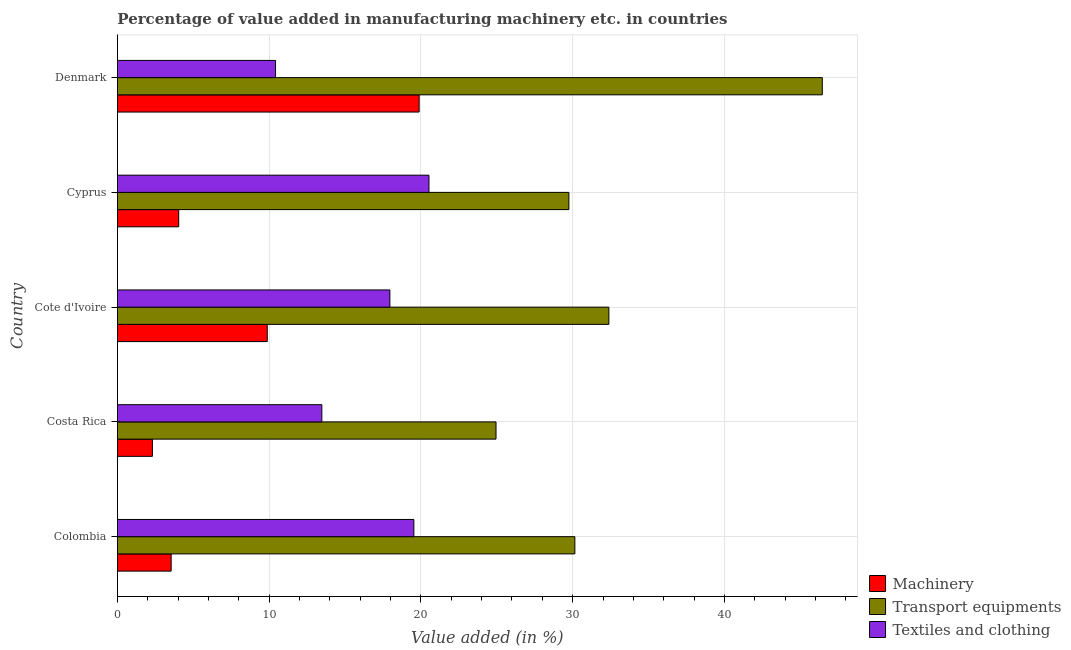How many groups of bars are there?
Keep it short and to the point. 5. Are the number of bars per tick equal to the number of legend labels?
Keep it short and to the point. Yes. How many bars are there on the 1st tick from the top?
Ensure brevity in your answer.  3. How many bars are there on the 3rd tick from the bottom?
Your answer should be very brief. 3. What is the label of the 2nd group of bars from the top?
Your response must be concise. Cyprus. In how many cases, is the number of bars for a given country not equal to the number of legend labels?
Keep it short and to the point. 0. What is the value added in manufacturing textile and clothing in Costa Rica?
Provide a short and direct response. 13.47. Across all countries, what is the maximum value added in manufacturing transport equipments?
Ensure brevity in your answer.  46.45. Across all countries, what is the minimum value added in manufacturing transport equipments?
Your answer should be very brief. 24.95. In which country was the value added in manufacturing textile and clothing maximum?
Provide a succinct answer. Cyprus. What is the total value added in manufacturing transport equipments in the graph?
Provide a short and direct response. 163.69. What is the difference between the value added in manufacturing machinery in Colombia and that in Cyprus?
Your answer should be compact. -0.5. What is the difference between the value added in manufacturing textile and clothing in Cote d'Ivoire and the value added in manufacturing transport equipments in Denmark?
Your response must be concise. -28.5. What is the average value added in manufacturing textile and clothing per country?
Ensure brevity in your answer.  16.38. What is the difference between the value added in manufacturing transport equipments and value added in manufacturing textile and clothing in Cyprus?
Offer a terse response. 9.22. What is the ratio of the value added in manufacturing transport equipments in Costa Rica to that in Cote d'Ivoire?
Give a very brief answer. 0.77. What is the difference between the highest and the second highest value added in manufacturing machinery?
Offer a very short reply. 10.01. In how many countries, is the value added in manufacturing machinery greater than the average value added in manufacturing machinery taken over all countries?
Your answer should be very brief. 2. What does the 1st bar from the top in Colombia represents?
Your answer should be very brief. Textiles and clothing. What does the 1st bar from the bottom in Cote d'Ivoire represents?
Offer a very short reply. Machinery. Is it the case that in every country, the sum of the value added in manufacturing machinery and value added in manufacturing transport equipments is greater than the value added in manufacturing textile and clothing?
Your answer should be very brief. Yes. How many bars are there?
Your answer should be very brief. 15. Are all the bars in the graph horizontal?
Your answer should be compact. Yes. How many countries are there in the graph?
Offer a terse response. 5. What is the difference between two consecutive major ticks on the X-axis?
Your answer should be compact. 10. Does the graph contain grids?
Keep it short and to the point. Yes. Where does the legend appear in the graph?
Offer a terse response. Bottom right. How many legend labels are there?
Provide a short and direct response. 3. What is the title of the graph?
Give a very brief answer. Percentage of value added in manufacturing machinery etc. in countries. What is the label or title of the X-axis?
Make the answer very short. Value added (in %). What is the Value added (in %) of Machinery in Colombia?
Provide a short and direct response. 3.54. What is the Value added (in %) in Transport equipments in Colombia?
Provide a succinct answer. 30.15. What is the Value added (in %) in Textiles and clothing in Colombia?
Ensure brevity in your answer.  19.54. What is the Value added (in %) in Machinery in Costa Rica?
Ensure brevity in your answer.  2.31. What is the Value added (in %) of Transport equipments in Costa Rica?
Make the answer very short. 24.95. What is the Value added (in %) of Textiles and clothing in Costa Rica?
Your response must be concise. 13.47. What is the Value added (in %) of Machinery in Cote d'Ivoire?
Provide a succinct answer. 9.88. What is the Value added (in %) of Transport equipments in Cote d'Ivoire?
Give a very brief answer. 32.39. What is the Value added (in %) in Textiles and clothing in Cote d'Ivoire?
Your response must be concise. 17.96. What is the Value added (in %) of Machinery in Cyprus?
Keep it short and to the point. 4.04. What is the Value added (in %) of Transport equipments in Cyprus?
Keep it short and to the point. 29.75. What is the Value added (in %) in Textiles and clothing in Cyprus?
Your answer should be very brief. 20.53. What is the Value added (in %) of Machinery in Denmark?
Provide a succinct answer. 19.88. What is the Value added (in %) of Transport equipments in Denmark?
Offer a terse response. 46.45. What is the Value added (in %) of Textiles and clothing in Denmark?
Offer a very short reply. 10.42. Across all countries, what is the maximum Value added (in %) in Machinery?
Give a very brief answer. 19.88. Across all countries, what is the maximum Value added (in %) in Transport equipments?
Provide a short and direct response. 46.45. Across all countries, what is the maximum Value added (in %) in Textiles and clothing?
Provide a short and direct response. 20.53. Across all countries, what is the minimum Value added (in %) in Machinery?
Offer a terse response. 2.31. Across all countries, what is the minimum Value added (in %) of Transport equipments?
Provide a succinct answer. 24.95. Across all countries, what is the minimum Value added (in %) of Textiles and clothing?
Your answer should be very brief. 10.42. What is the total Value added (in %) in Machinery in the graph?
Your answer should be very brief. 39.65. What is the total Value added (in %) in Transport equipments in the graph?
Provide a short and direct response. 163.69. What is the total Value added (in %) in Textiles and clothing in the graph?
Provide a short and direct response. 81.92. What is the difference between the Value added (in %) of Machinery in Colombia and that in Costa Rica?
Make the answer very short. 1.24. What is the difference between the Value added (in %) of Transport equipments in Colombia and that in Costa Rica?
Keep it short and to the point. 5.2. What is the difference between the Value added (in %) in Textiles and clothing in Colombia and that in Costa Rica?
Offer a terse response. 6.06. What is the difference between the Value added (in %) of Machinery in Colombia and that in Cote d'Ivoire?
Provide a succinct answer. -6.33. What is the difference between the Value added (in %) of Transport equipments in Colombia and that in Cote d'Ivoire?
Your answer should be very brief. -2.24. What is the difference between the Value added (in %) in Textiles and clothing in Colombia and that in Cote d'Ivoire?
Make the answer very short. 1.58. What is the difference between the Value added (in %) in Machinery in Colombia and that in Cyprus?
Your response must be concise. -0.5. What is the difference between the Value added (in %) of Transport equipments in Colombia and that in Cyprus?
Give a very brief answer. 0.39. What is the difference between the Value added (in %) of Textiles and clothing in Colombia and that in Cyprus?
Make the answer very short. -0.99. What is the difference between the Value added (in %) of Machinery in Colombia and that in Denmark?
Ensure brevity in your answer.  -16.34. What is the difference between the Value added (in %) in Transport equipments in Colombia and that in Denmark?
Your answer should be very brief. -16.31. What is the difference between the Value added (in %) in Textiles and clothing in Colombia and that in Denmark?
Keep it short and to the point. 9.12. What is the difference between the Value added (in %) of Machinery in Costa Rica and that in Cote d'Ivoire?
Offer a terse response. -7.57. What is the difference between the Value added (in %) in Transport equipments in Costa Rica and that in Cote d'Ivoire?
Offer a terse response. -7.44. What is the difference between the Value added (in %) in Textiles and clothing in Costa Rica and that in Cote d'Ivoire?
Ensure brevity in your answer.  -4.48. What is the difference between the Value added (in %) in Machinery in Costa Rica and that in Cyprus?
Offer a very short reply. -1.73. What is the difference between the Value added (in %) in Transport equipments in Costa Rica and that in Cyprus?
Make the answer very short. -4.8. What is the difference between the Value added (in %) in Textiles and clothing in Costa Rica and that in Cyprus?
Make the answer very short. -7.06. What is the difference between the Value added (in %) in Machinery in Costa Rica and that in Denmark?
Keep it short and to the point. -17.58. What is the difference between the Value added (in %) of Transport equipments in Costa Rica and that in Denmark?
Offer a very short reply. -21.5. What is the difference between the Value added (in %) of Textiles and clothing in Costa Rica and that in Denmark?
Ensure brevity in your answer.  3.05. What is the difference between the Value added (in %) of Machinery in Cote d'Ivoire and that in Cyprus?
Your answer should be compact. 5.84. What is the difference between the Value added (in %) in Transport equipments in Cote d'Ivoire and that in Cyprus?
Offer a terse response. 2.63. What is the difference between the Value added (in %) of Textiles and clothing in Cote d'Ivoire and that in Cyprus?
Offer a terse response. -2.58. What is the difference between the Value added (in %) of Machinery in Cote d'Ivoire and that in Denmark?
Offer a very short reply. -10.01. What is the difference between the Value added (in %) in Transport equipments in Cote d'Ivoire and that in Denmark?
Ensure brevity in your answer.  -14.06. What is the difference between the Value added (in %) of Textiles and clothing in Cote d'Ivoire and that in Denmark?
Your answer should be compact. 7.53. What is the difference between the Value added (in %) in Machinery in Cyprus and that in Denmark?
Ensure brevity in your answer.  -15.84. What is the difference between the Value added (in %) in Transport equipments in Cyprus and that in Denmark?
Your answer should be compact. -16.7. What is the difference between the Value added (in %) of Textiles and clothing in Cyprus and that in Denmark?
Give a very brief answer. 10.11. What is the difference between the Value added (in %) of Machinery in Colombia and the Value added (in %) of Transport equipments in Costa Rica?
Provide a succinct answer. -21.41. What is the difference between the Value added (in %) of Machinery in Colombia and the Value added (in %) of Textiles and clothing in Costa Rica?
Make the answer very short. -9.93. What is the difference between the Value added (in %) of Transport equipments in Colombia and the Value added (in %) of Textiles and clothing in Costa Rica?
Offer a terse response. 16.67. What is the difference between the Value added (in %) in Machinery in Colombia and the Value added (in %) in Transport equipments in Cote d'Ivoire?
Ensure brevity in your answer.  -28.85. What is the difference between the Value added (in %) in Machinery in Colombia and the Value added (in %) in Textiles and clothing in Cote d'Ivoire?
Your response must be concise. -14.41. What is the difference between the Value added (in %) in Transport equipments in Colombia and the Value added (in %) in Textiles and clothing in Cote d'Ivoire?
Ensure brevity in your answer.  12.19. What is the difference between the Value added (in %) in Machinery in Colombia and the Value added (in %) in Transport equipments in Cyprus?
Your answer should be very brief. -26.21. What is the difference between the Value added (in %) of Machinery in Colombia and the Value added (in %) of Textiles and clothing in Cyprus?
Keep it short and to the point. -16.99. What is the difference between the Value added (in %) of Transport equipments in Colombia and the Value added (in %) of Textiles and clothing in Cyprus?
Give a very brief answer. 9.61. What is the difference between the Value added (in %) of Machinery in Colombia and the Value added (in %) of Transport equipments in Denmark?
Keep it short and to the point. -42.91. What is the difference between the Value added (in %) of Machinery in Colombia and the Value added (in %) of Textiles and clothing in Denmark?
Provide a succinct answer. -6.88. What is the difference between the Value added (in %) in Transport equipments in Colombia and the Value added (in %) in Textiles and clothing in Denmark?
Offer a terse response. 19.72. What is the difference between the Value added (in %) in Machinery in Costa Rica and the Value added (in %) in Transport equipments in Cote d'Ivoire?
Provide a succinct answer. -30.08. What is the difference between the Value added (in %) in Machinery in Costa Rica and the Value added (in %) in Textiles and clothing in Cote d'Ivoire?
Provide a short and direct response. -15.65. What is the difference between the Value added (in %) of Transport equipments in Costa Rica and the Value added (in %) of Textiles and clothing in Cote d'Ivoire?
Your response must be concise. 6.99. What is the difference between the Value added (in %) of Machinery in Costa Rica and the Value added (in %) of Transport equipments in Cyprus?
Give a very brief answer. -27.45. What is the difference between the Value added (in %) in Machinery in Costa Rica and the Value added (in %) in Textiles and clothing in Cyprus?
Ensure brevity in your answer.  -18.23. What is the difference between the Value added (in %) of Transport equipments in Costa Rica and the Value added (in %) of Textiles and clothing in Cyprus?
Your response must be concise. 4.42. What is the difference between the Value added (in %) of Machinery in Costa Rica and the Value added (in %) of Transport equipments in Denmark?
Your response must be concise. -44.15. What is the difference between the Value added (in %) of Machinery in Costa Rica and the Value added (in %) of Textiles and clothing in Denmark?
Offer a very short reply. -8.11. What is the difference between the Value added (in %) of Transport equipments in Costa Rica and the Value added (in %) of Textiles and clothing in Denmark?
Offer a terse response. 14.53. What is the difference between the Value added (in %) of Machinery in Cote d'Ivoire and the Value added (in %) of Transport equipments in Cyprus?
Offer a very short reply. -19.88. What is the difference between the Value added (in %) of Machinery in Cote d'Ivoire and the Value added (in %) of Textiles and clothing in Cyprus?
Provide a succinct answer. -10.66. What is the difference between the Value added (in %) in Transport equipments in Cote d'Ivoire and the Value added (in %) in Textiles and clothing in Cyprus?
Ensure brevity in your answer.  11.86. What is the difference between the Value added (in %) in Machinery in Cote d'Ivoire and the Value added (in %) in Transport equipments in Denmark?
Offer a terse response. -36.58. What is the difference between the Value added (in %) in Machinery in Cote d'Ivoire and the Value added (in %) in Textiles and clothing in Denmark?
Make the answer very short. -0.55. What is the difference between the Value added (in %) of Transport equipments in Cote d'Ivoire and the Value added (in %) of Textiles and clothing in Denmark?
Your answer should be very brief. 21.97. What is the difference between the Value added (in %) of Machinery in Cyprus and the Value added (in %) of Transport equipments in Denmark?
Provide a short and direct response. -42.41. What is the difference between the Value added (in %) in Machinery in Cyprus and the Value added (in %) in Textiles and clothing in Denmark?
Your answer should be very brief. -6.38. What is the difference between the Value added (in %) of Transport equipments in Cyprus and the Value added (in %) of Textiles and clothing in Denmark?
Give a very brief answer. 19.33. What is the average Value added (in %) of Machinery per country?
Make the answer very short. 7.93. What is the average Value added (in %) of Transport equipments per country?
Ensure brevity in your answer.  32.74. What is the average Value added (in %) of Textiles and clothing per country?
Ensure brevity in your answer.  16.38. What is the difference between the Value added (in %) of Machinery and Value added (in %) of Transport equipments in Colombia?
Provide a short and direct response. -26.6. What is the difference between the Value added (in %) of Machinery and Value added (in %) of Textiles and clothing in Colombia?
Give a very brief answer. -15.99. What is the difference between the Value added (in %) of Transport equipments and Value added (in %) of Textiles and clothing in Colombia?
Your answer should be very brief. 10.61. What is the difference between the Value added (in %) in Machinery and Value added (in %) in Transport equipments in Costa Rica?
Your answer should be compact. -22.64. What is the difference between the Value added (in %) of Machinery and Value added (in %) of Textiles and clothing in Costa Rica?
Provide a succinct answer. -11.17. What is the difference between the Value added (in %) in Transport equipments and Value added (in %) in Textiles and clothing in Costa Rica?
Give a very brief answer. 11.48. What is the difference between the Value added (in %) of Machinery and Value added (in %) of Transport equipments in Cote d'Ivoire?
Your answer should be very brief. -22.51. What is the difference between the Value added (in %) in Machinery and Value added (in %) in Textiles and clothing in Cote d'Ivoire?
Provide a succinct answer. -8.08. What is the difference between the Value added (in %) in Transport equipments and Value added (in %) in Textiles and clothing in Cote d'Ivoire?
Provide a short and direct response. 14.43. What is the difference between the Value added (in %) of Machinery and Value added (in %) of Transport equipments in Cyprus?
Give a very brief answer. -25.71. What is the difference between the Value added (in %) of Machinery and Value added (in %) of Textiles and clothing in Cyprus?
Your answer should be very brief. -16.49. What is the difference between the Value added (in %) of Transport equipments and Value added (in %) of Textiles and clothing in Cyprus?
Ensure brevity in your answer.  9.22. What is the difference between the Value added (in %) of Machinery and Value added (in %) of Transport equipments in Denmark?
Give a very brief answer. -26.57. What is the difference between the Value added (in %) of Machinery and Value added (in %) of Textiles and clothing in Denmark?
Make the answer very short. 9.46. What is the difference between the Value added (in %) of Transport equipments and Value added (in %) of Textiles and clothing in Denmark?
Keep it short and to the point. 36.03. What is the ratio of the Value added (in %) of Machinery in Colombia to that in Costa Rica?
Your answer should be compact. 1.54. What is the ratio of the Value added (in %) in Transport equipments in Colombia to that in Costa Rica?
Make the answer very short. 1.21. What is the ratio of the Value added (in %) of Textiles and clothing in Colombia to that in Costa Rica?
Your answer should be very brief. 1.45. What is the ratio of the Value added (in %) of Machinery in Colombia to that in Cote d'Ivoire?
Provide a short and direct response. 0.36. What is the ratio of the Value added (in %) in Transport equipments in Colombia to that in Cote d'Ivoire?
Your answer should be very brief. 0.93. What is the ratio of the Value added (in %) in Textiles and clothing in Colombia to that in Cote d'Ivoire?
Your answer should be compact. 1.09. What is the ratio of the Value added (in %) of Machinery in Colombia to that in Cyprus?
Ensure brevity in your answer.  0.88. What is the ratio of the Value added (in %) in Transport equipments in Colombia to that in Cyprus?
Provide a short and direct response. 1.01. What is the ratio of the Value added (in %) in Textiles and clothing in Colombia to that in Cyprus?
Provide a short and direct response. 0.95. What is the ratio of the Value added (in %) in Machinery in Colombia to that in Denmark?
Offer a very short reply. 0.18. What is the ratio of the Value added (in %) in Transport equipments in Colombia to that in Denmark?
Your response must be concise. 0.65. What is the ratio of the Value added (in %) in Textiles and clothing in Colombia to that in Denmark?
Make the answer very short. 1.87. What is the ratio of the Value added (in %) of Machinery in Costa Rica to that in Cote d'Ivoire?
Provide a succinct answer. 0.23. What is the ratio of the Value added (in %) of Transport equipments in Costa Rica to that in Cote d'Ivoire?
Your answer should be very brief. 0.77. What is the ratio of the Value added (in %) of Textiles and clothing in Costa Rica to that in Cote d'Ivoire?
Offer a terse response. 0.75. What is the ratio of the Value added (in %) in Machinery in Costa Rica to that in Cyprus?
Your answer should be very brief. 0.57. What is the ratio of the Value added (in %) of Transport equipments in Costa Rica to that in Cyprus?
Your response must be concise. 0.84. What is the ratio of the Value added (in %) of Textiles and clothing in Costa Rica to that in Cyprus?
Give a very brief answer. 0.66. What is the ratio of the Value added (in %) in Machinery in Costa Rica to that in Denmark?
Offer a very short reply. 0.12. What is the ratio of the Value added (in %) in Transport equipments in Costa Rica to that in Denmark?
Give a very brief answer. 0.54. What is the ratio of the Value added (in %) of Textiles and clothing in Costa Rica to that in Denmark?
Your answer should be very brief. 1.29. What is the ratio of the Value added (in %) in Machinery in Cote d'Ivoire to that in Cyprus?
Your answer should be compact. 2.44. What is the ratio of the Value added (in %) in Transport equipments in Cote d'Ivoire to that in Cyprus?
Provide a succinct answer. 1.09. What is the ratio of the Value added (in %) in Textiles and clothing in Cote d'Ivoire to that in Cyprus?
Provide a short and direct response. 0.87. What is the ratio of the Value added (in %) in Machinery in Cote d'Ivoire to that in Denmark?
Your answer should be very brief. 0.5. What is the ratio of the Value added (in %) of Transport equipments in Cote d'Ivoire to that in Denmark?
Provide a succinct answer. 0.7. What is the ratio of the Value added (in %) in Textiles and clothing in Cote d'Ivoire to that in Denmark?
Ensure brevity in your answer.  1.72. What is the ratio of the Value added (in %) of Machinery in Cyprus to that in Denmark?
Make the answer very short. 0.2. What is the ratio of the Value added (in %) in Transport equipments in Cyprus to that in Denmark?
Your answer should be very brief. 0.64. What is the ratio of the Value added (in %) in Textiles and clothing in Cyprus to that in Denmark?
Your response must be concise. 1.97. What is the difference between the highest and the second highest Value added (in %) of Machinery?
Your answer should be compact. 10.01. What is the difference between the highest and the second highest Value added (in %) of Transport equipments?
Offer a very short reply. 14.06. What is the difference between the highest and the second highest Value added (in %) in Textiles and clothing?
Give a very brief answer. 0.99. What is the difference between the highest and the lowest Value added (in %) of Machinery?
Provide a short and direct response. 17.58. What is the difference between the highest and the lowest Value added (in %) of Transport equipments?
Offer a very short reply. 21.5. What is the difference between the highest and the lowest Value added (in %) of Textiles and clothing?
Your answer should be very brief. 10.11. 